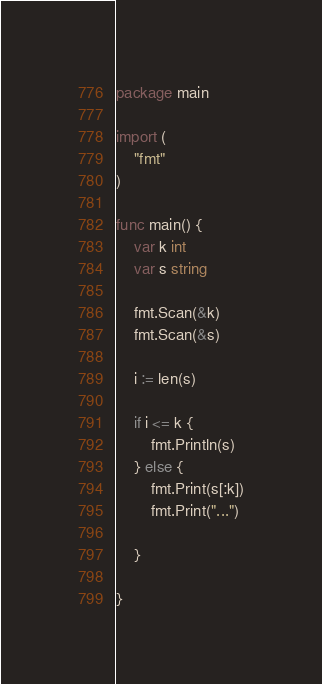<code> <loc_0><loc_0><loc_500><loc_500><_Go_>package main

import (
	"fmt"
)

func main() {
	var k int
	var s string

	fmt.Scan(&k)
	fmt.Scan(&s)

	i := len(s)

	if i <= k {
		fmt.Println(s)
	} else {
		fmt.Print(s[:k])
		fmt.Print("...")

	}

}
</code> 